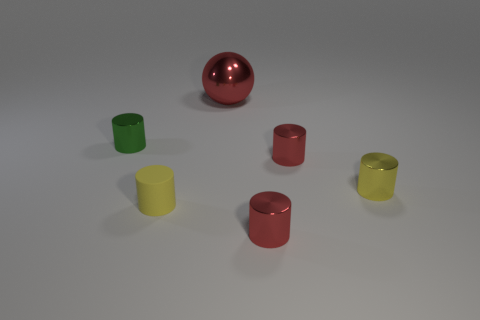What is the color of the big shiny ball?
Give a very brief answer. Red. Do the rubber thing and the metal ball have the same color?
Give a very brief answer. No. How many rubber objects are big red objects or green cylinders?
Keep it short and to the point. 0. There is a tiny yellow cylinder that is right of the object that is behind the tiny green cylinder; are there any red objects that are behind it?
Offer a terse response. Yes. What size is the red sphere that is the same material as the tiny green cylinder?
Keep it short and to the point. Large. There is a tiny green metallic thing; are there any yellow objects in front of it?
Give a very brief answer. Yes. There is a metal object in front of the small yellow rubber object; are there any red shiny cylinders on the left side of it?
Your response must be concise. No. There is a yellow cylinder that is on the left side of the big red object; is its size the same as the red ball behind the matte thing?
Your response must be concise. No. How many small objects are yellow cylinders or red spheres?
Keep it short and to the point. 2. The small red cylinder that is behind the small red shiny cylinder in front of the tiny rubber cylinder is made of what material?
Your response must be concise. Metal. 